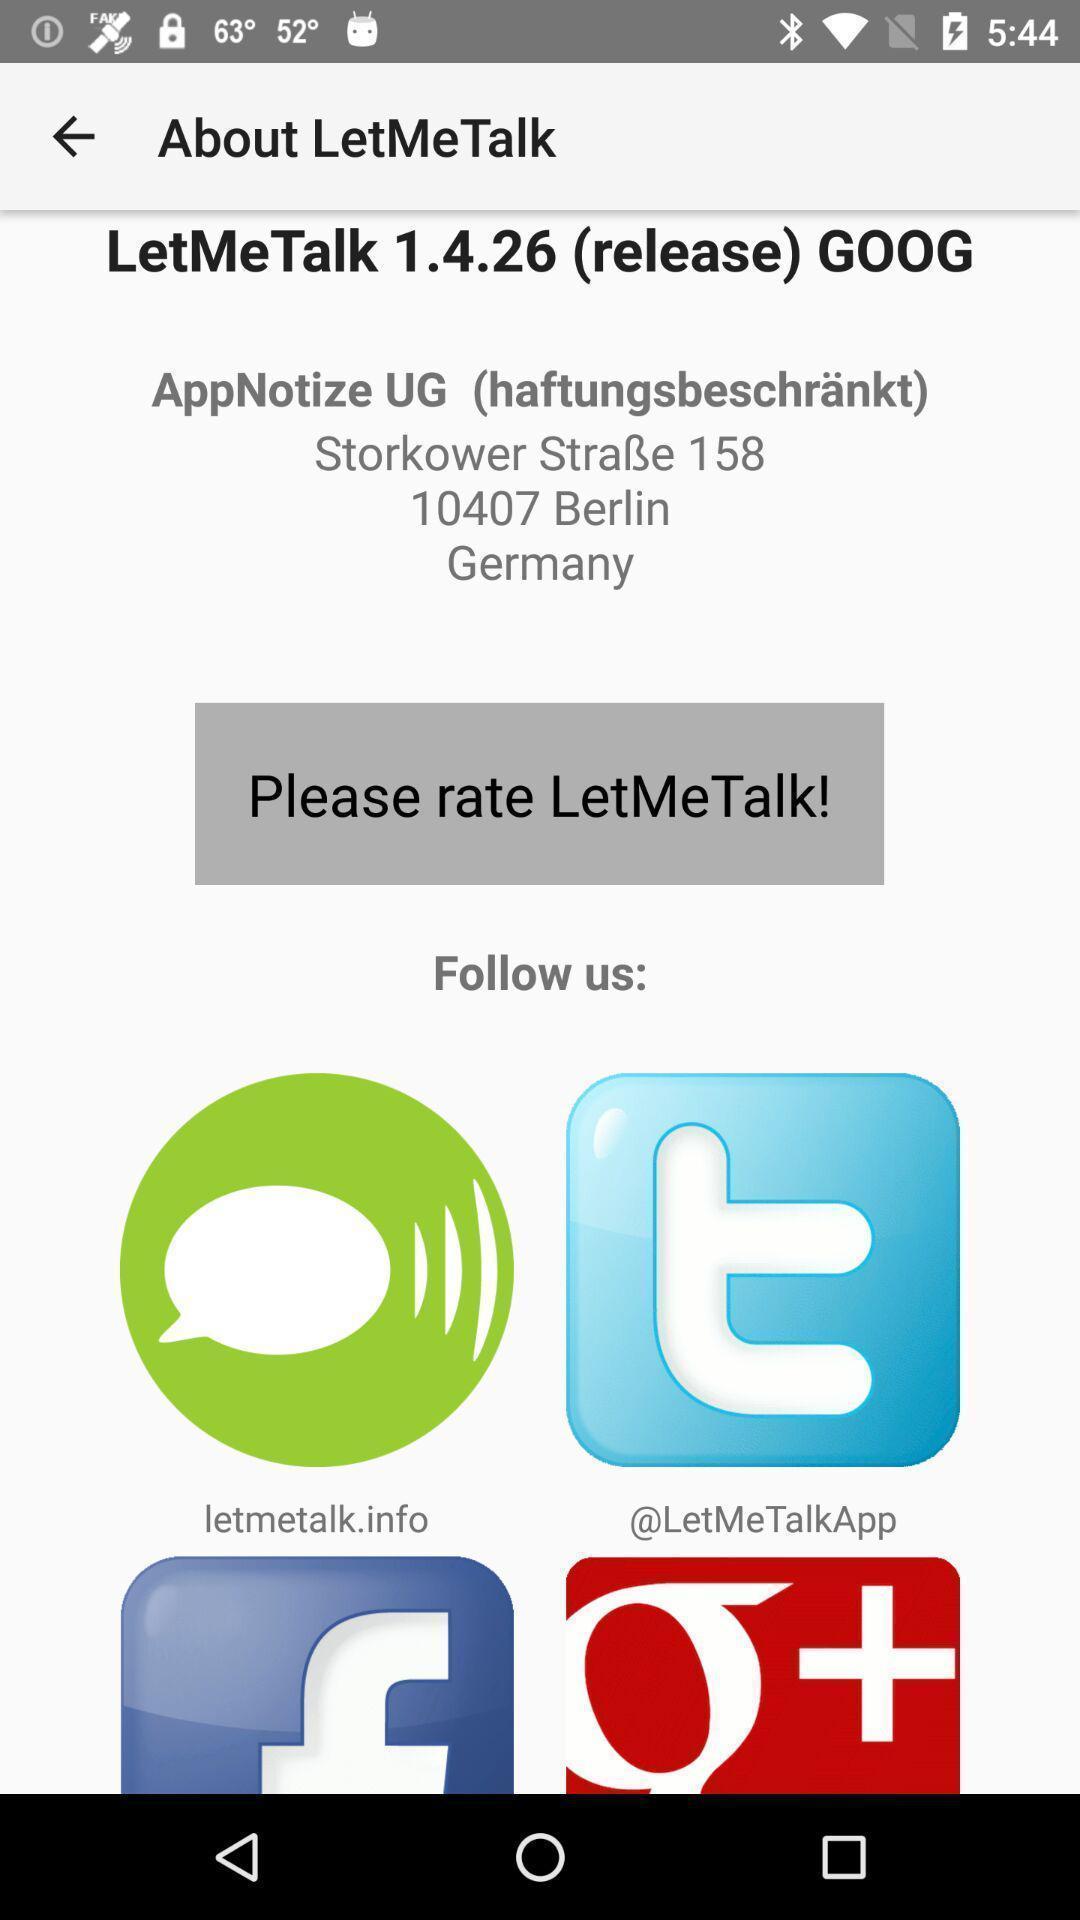Give me a narrative description of this picture. Page displaying for rating the application in talker application. 